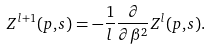<formula> <loc_0><loc_0><loc_500><loc_500>Z ^ { l + 1 } ( p , s ) = - \frac { 1 } { l } \frac { \partial } { \partial \beta ^ { 2 } } Z ^ { l } ( p , s ) .</formula> 